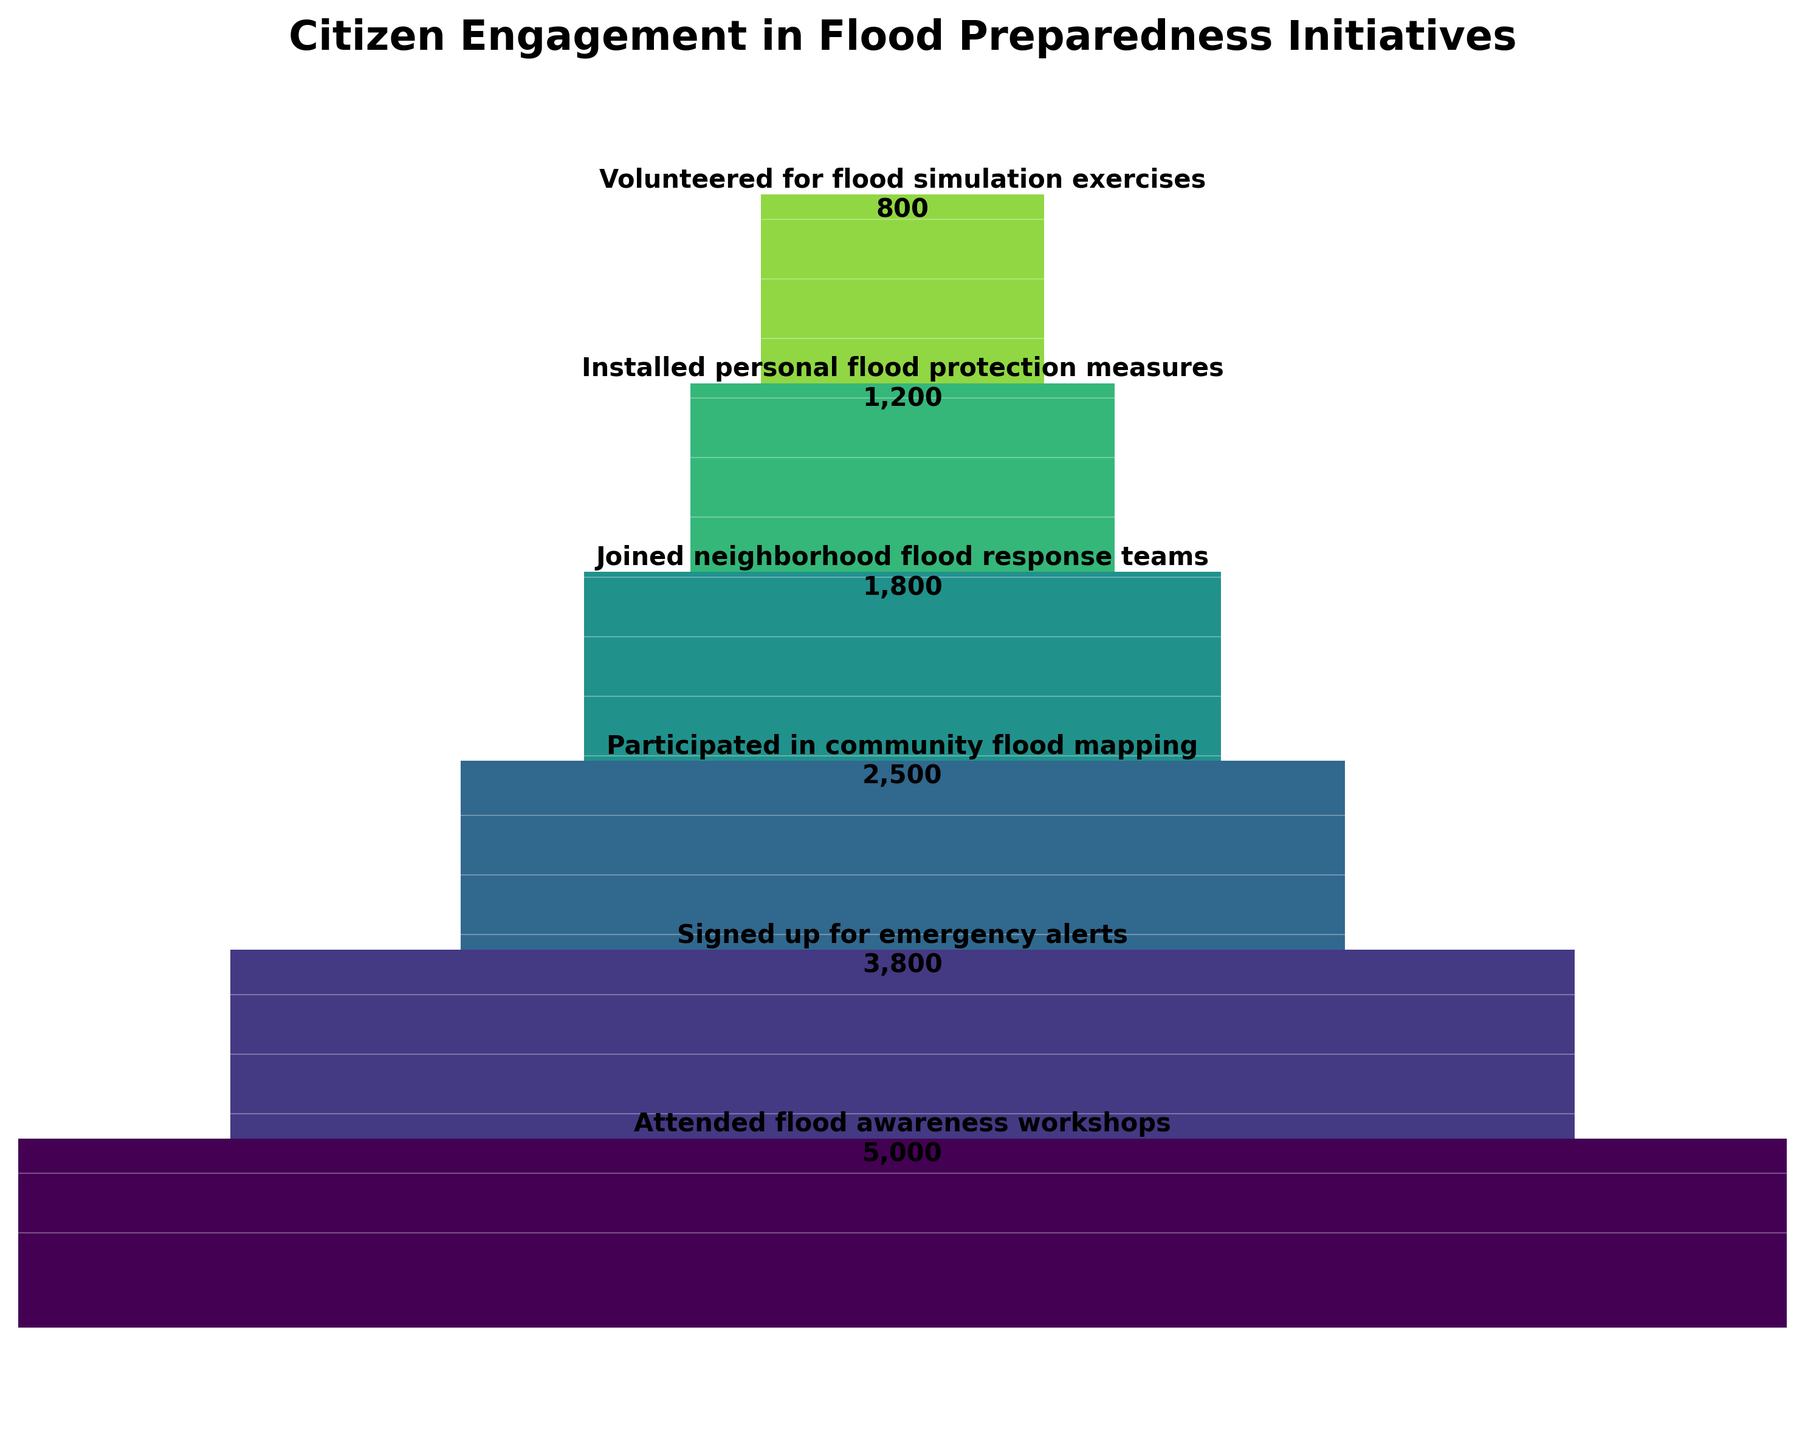What is the title of the plot? The title is usually placed at the top of the plot and is often bold to draw attention. It provides context about what the data represents.
Answer: Citizen Engagement in Flood Preparedness Initiatives How many categories are shown in the funnel chart? By counting the distinct labels on the y-axis or in the generalized sections of the funnel chart, you can determine the number of categories.
Answer: 6 Which category has the highest number of citizens participating? The widest section of the funnel at the top represents the category with the highest participation.
Answer: Attended flood awareness workshops How many more citizens signed up for emergency alerts compared to those who joined neighborhood flood response teams? First, identify the values from the plot, then subtract the number of citizens who joined neighborhood flood response teams (1800) from those who signed up for emergency alerts (3800). 3800 - 1800 = 2000
Answer: 2000 What is the cumulative number of citizens involved in all flood preparedness initiatives shown? Sum the number of citizens in each category: 5000 (workshops) + 3800 (alerts) + 2500 (mapping) + 1800 (response teams) + 1200 (protection measures) + 800 (simulation exercises). 5000 + 3800 + 2500 + 1800 + 1200 + 800 = 15100
Answer: 15100 What percentage of citizens who attended flood awareness workshops also participated in community flood mapping? Calculate the ratio of citizens who participated in flood mapping to those who attended workshops: (2500 / 5000) * 100%. (2500 / 5000) * 100 = 50%
Answer: 50% Which categories show a greater than 50% decrease in participation compared to the previous category? Examine the funnel to see where the width of the sections vastly decreases. Compare: 
- Sign-up alerts (3800) vs. workshops (5000): 5000 - 3800 = 1200, (1200 / 5000) * 100 = 24%
- Mapping (2500) vs. alerts (3800): 3800 - 2500 = 1300, (1300 / 3800) * 100 ≈ 34%
- Response teams (1800) vs. mapping (2500): 2500 - 1800 = 700, (700 / 2500) * 100 ≈ 28%
- Protection measures (1200) vs. response teams (1800): 1800 - 1200 = 600, (600 / 1800) * 100 ≈ 33%
- Simulation exercises (800) vs. protection measures (1200): 1200 - 800 = 400, (400 / 1200) * 100 ≈ 33%
No category shows a greater than 50% decrease
Answer: None How many more citizens participated in community flood mapping than installed personal flood protection measures? Subtract the number of citizens installing personal flood protection measures (1200) from those participating in community flood mapping (2500). 2500 - 1200 = 1300
Answer: 1300 Which data point indicates the least citizen involvement and what is its value? The narrowest section at the bottom of the funnel represents the category with the least participation.
Answer: Volunteered for flood simulation exercises, 800 